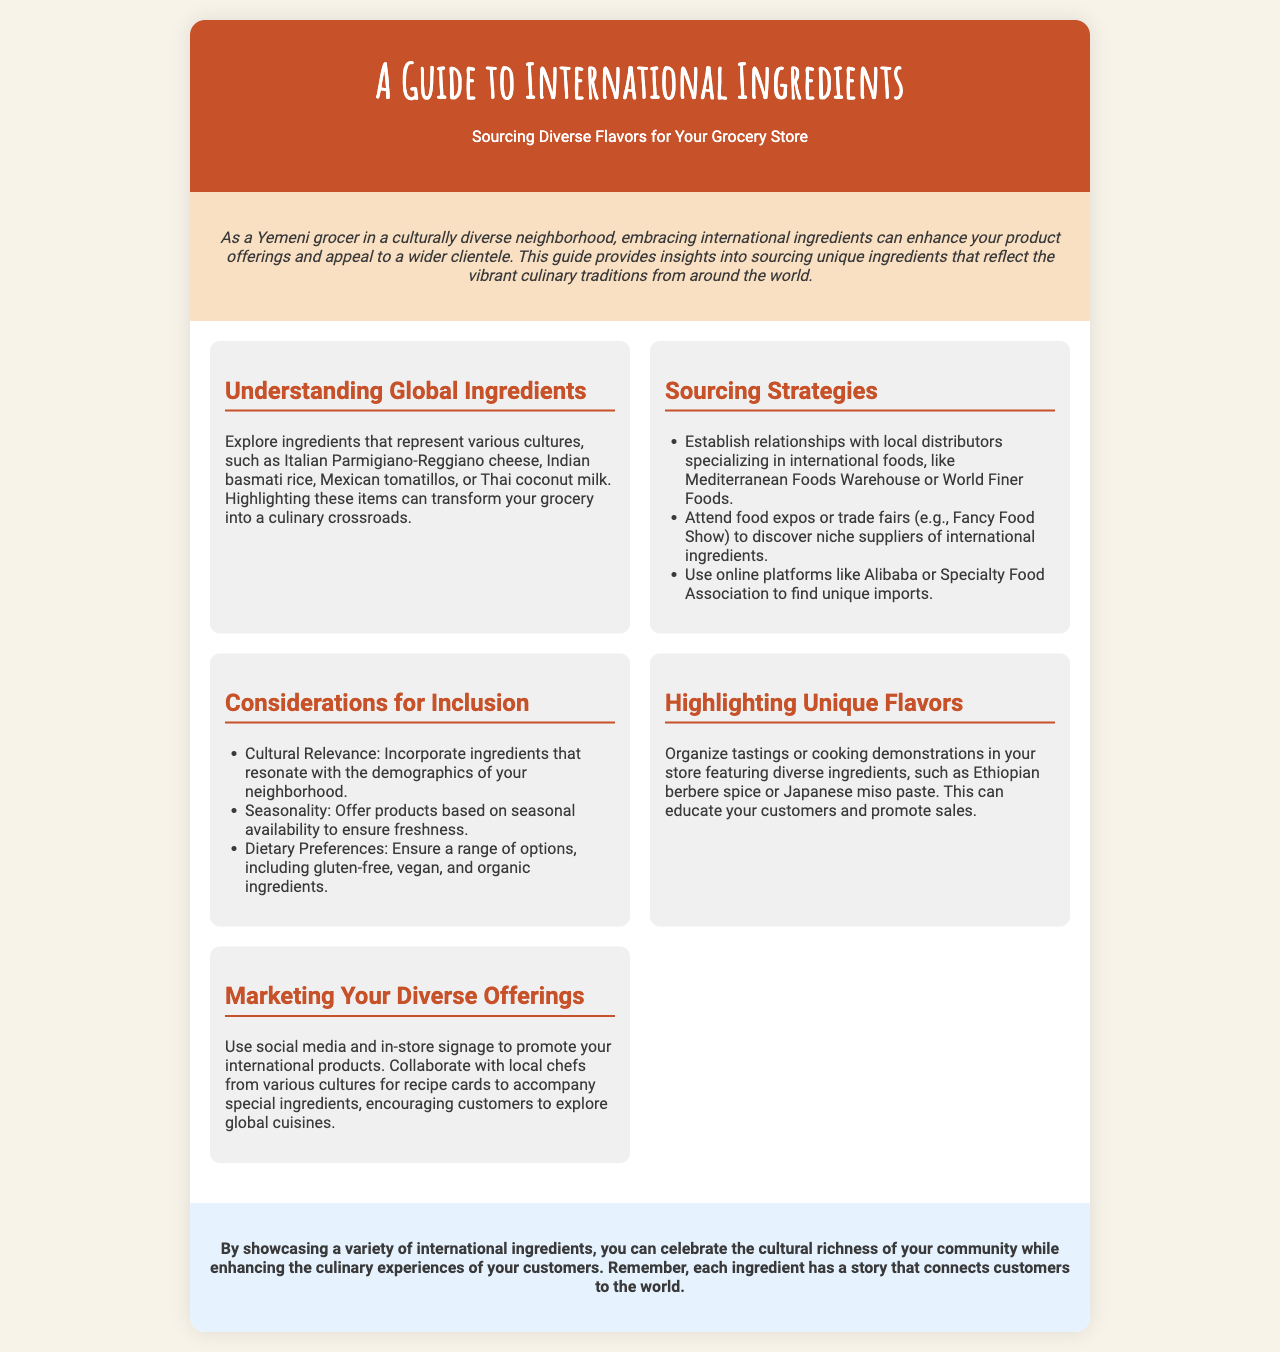What is the title of the brochure? The title is mentioned prominently at the top of the document.
Answer: A Guide to International Ingredients What is the primary focus of the guide? The primary focus can be inferred from the subtitle and introductory text.
Answer: Sourcing Diverse Flavors for Your Grocery Store Which cheese is mentioned as an example of a global ingredient? The document provides specific examples of international ingredients.
Answer: Parmigiano-Reggiano What type of food fairs are suggested for discovering suppliers? The document lists events that can help in sourcing international ingredients.
Answer: Fancy Food Show What is one cultural consideration for including ingredients? The document emphasizes important factors to consider when sourcing ingredients.
Answer: Cultural Relevance What method is suggested for promoting international products? The brochure includes marketing strategies tailored for diverse offerings.
Answer: Social media Name an online platform for finding unique imports. The document lists online resources for sourcing ingredients.
Answer: Alibaba What is one way to educate customers about diverse ingredients? The section on highlighting unique flavors suggests customer engagement methods.
Answer: Tastings How can local chefs contribute to grocery marketing? The document highlights collaborations to enrich customer experience.
Answer: Recipe cards 